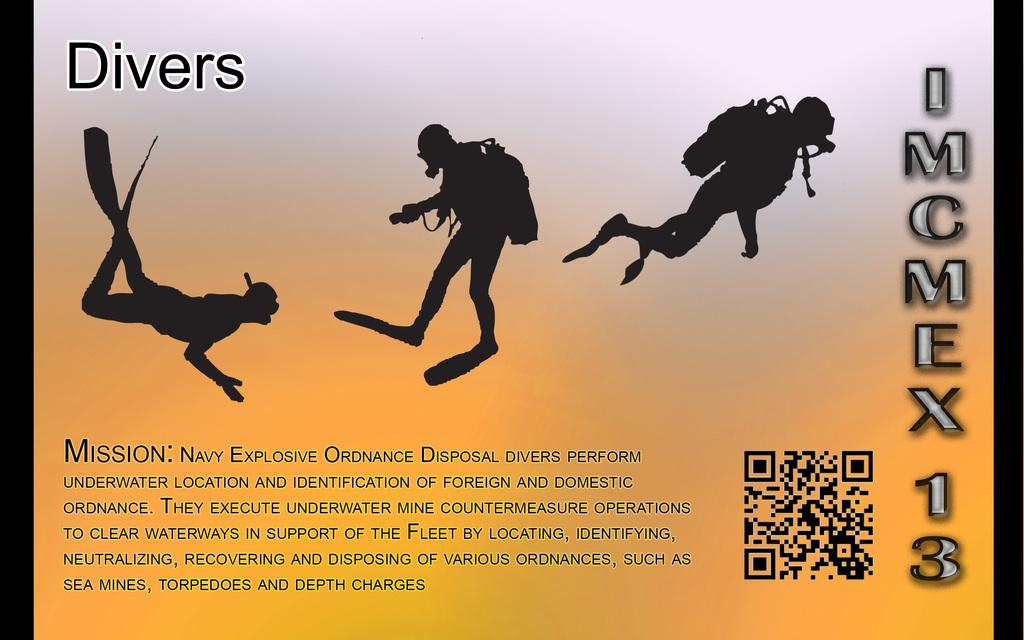What is the main subject of the image? The image contains pictures of a person. Are there any written words in the image? Yes, there is text in the image. What type of symbol can be seen in the image? There is a barcode in the image. Can you tell me how many goats are in the image? There are no goats present in the image; it contains pictures of a person, text, and a barcode. 